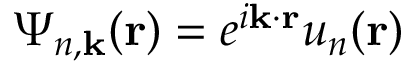Convert formula to latex. <formula><loc_0><loc_0><loc_500><loc_500>{ \Psi } _ { n , k } ( r ) = e ^ { i k \cdot r } u _ { n } ( r )</formula> 